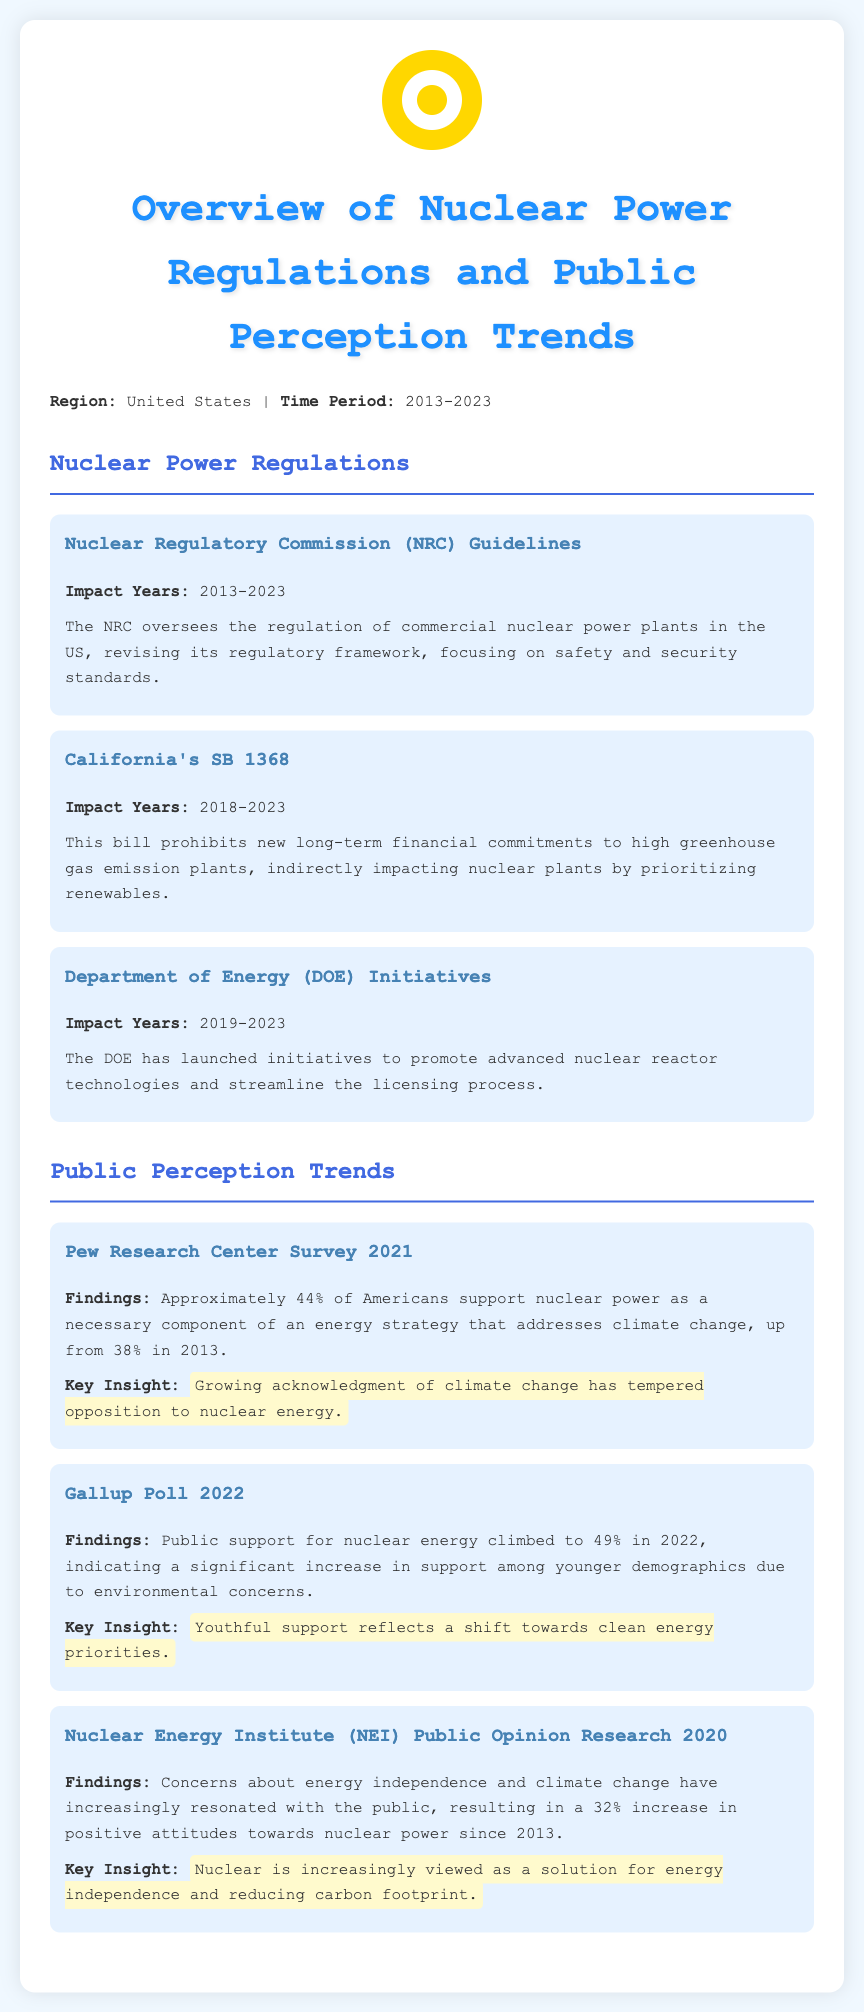What does NRC stand for? The document mentions that NRC stands for Nuclear Regulatory Commission, which is responsible for regulating commercial nuclear power plants in the US.
Answer: Nuclear Regulatory Commission What year did California's SB 1368 impact start? The document specifies that California's SB 1368 had an impact starting in 2018.
Answer: 2018 What percentage of Americans supported nuclear power according to the Pew Research Center survey in 2021? The document cites that approximately 44% of Americans supported nuclear power in 2021.
Answer: 44% Which demographic showed increased support for nuclear energy in 2022? The document indicates that support among younger demographics significantly increased for nuclear energy in 2022.
Answer: Younger demographics What was the percentage increase in positive attitudes towards nuclear power since 2013 according to NEI research? The document states that there was a 32% increase in positive attitudes towards nuclear power since 2013.
Answer: 32% Which agency launched initiatives to promote advanced nuclear reactor technologies? The document mentions that the Department of Energy (DOE) launched initiatives for advanced nuclear reactors.
Answer: Department of Energy What is the focus of NRC's regulatory framework? The document points out that NRC's regulatory framework focuses on safety and security standards.
Answer: Safety and security standards What key insight highlights the public perception trend regarding nuclear energy? The document emphasizes that growing acknowledgment of climate change has tempered opposition to nuclear energy.
Answer: Growing acknowledgment of climate change What is the main consequence of California's SB 1368 for nuclear plants? The document explains that California's SB 1368 prohibits new long-term financial commitments to high greenhouse gas emission plants, indirectly impacting nuclear plants.
Answer: Indirectly impacting nuclear plants 